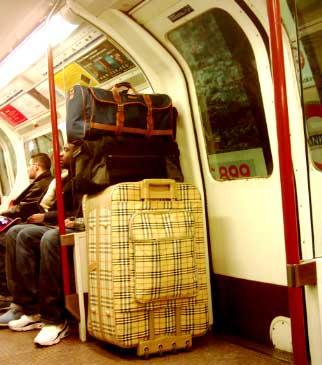What is the large yellow object in the center of the picture?
Quick response, please. Suitcase. What color are the poles?
Short answer required. Red. What type of vehicle are the people riding in?
Short answer required. Train. 